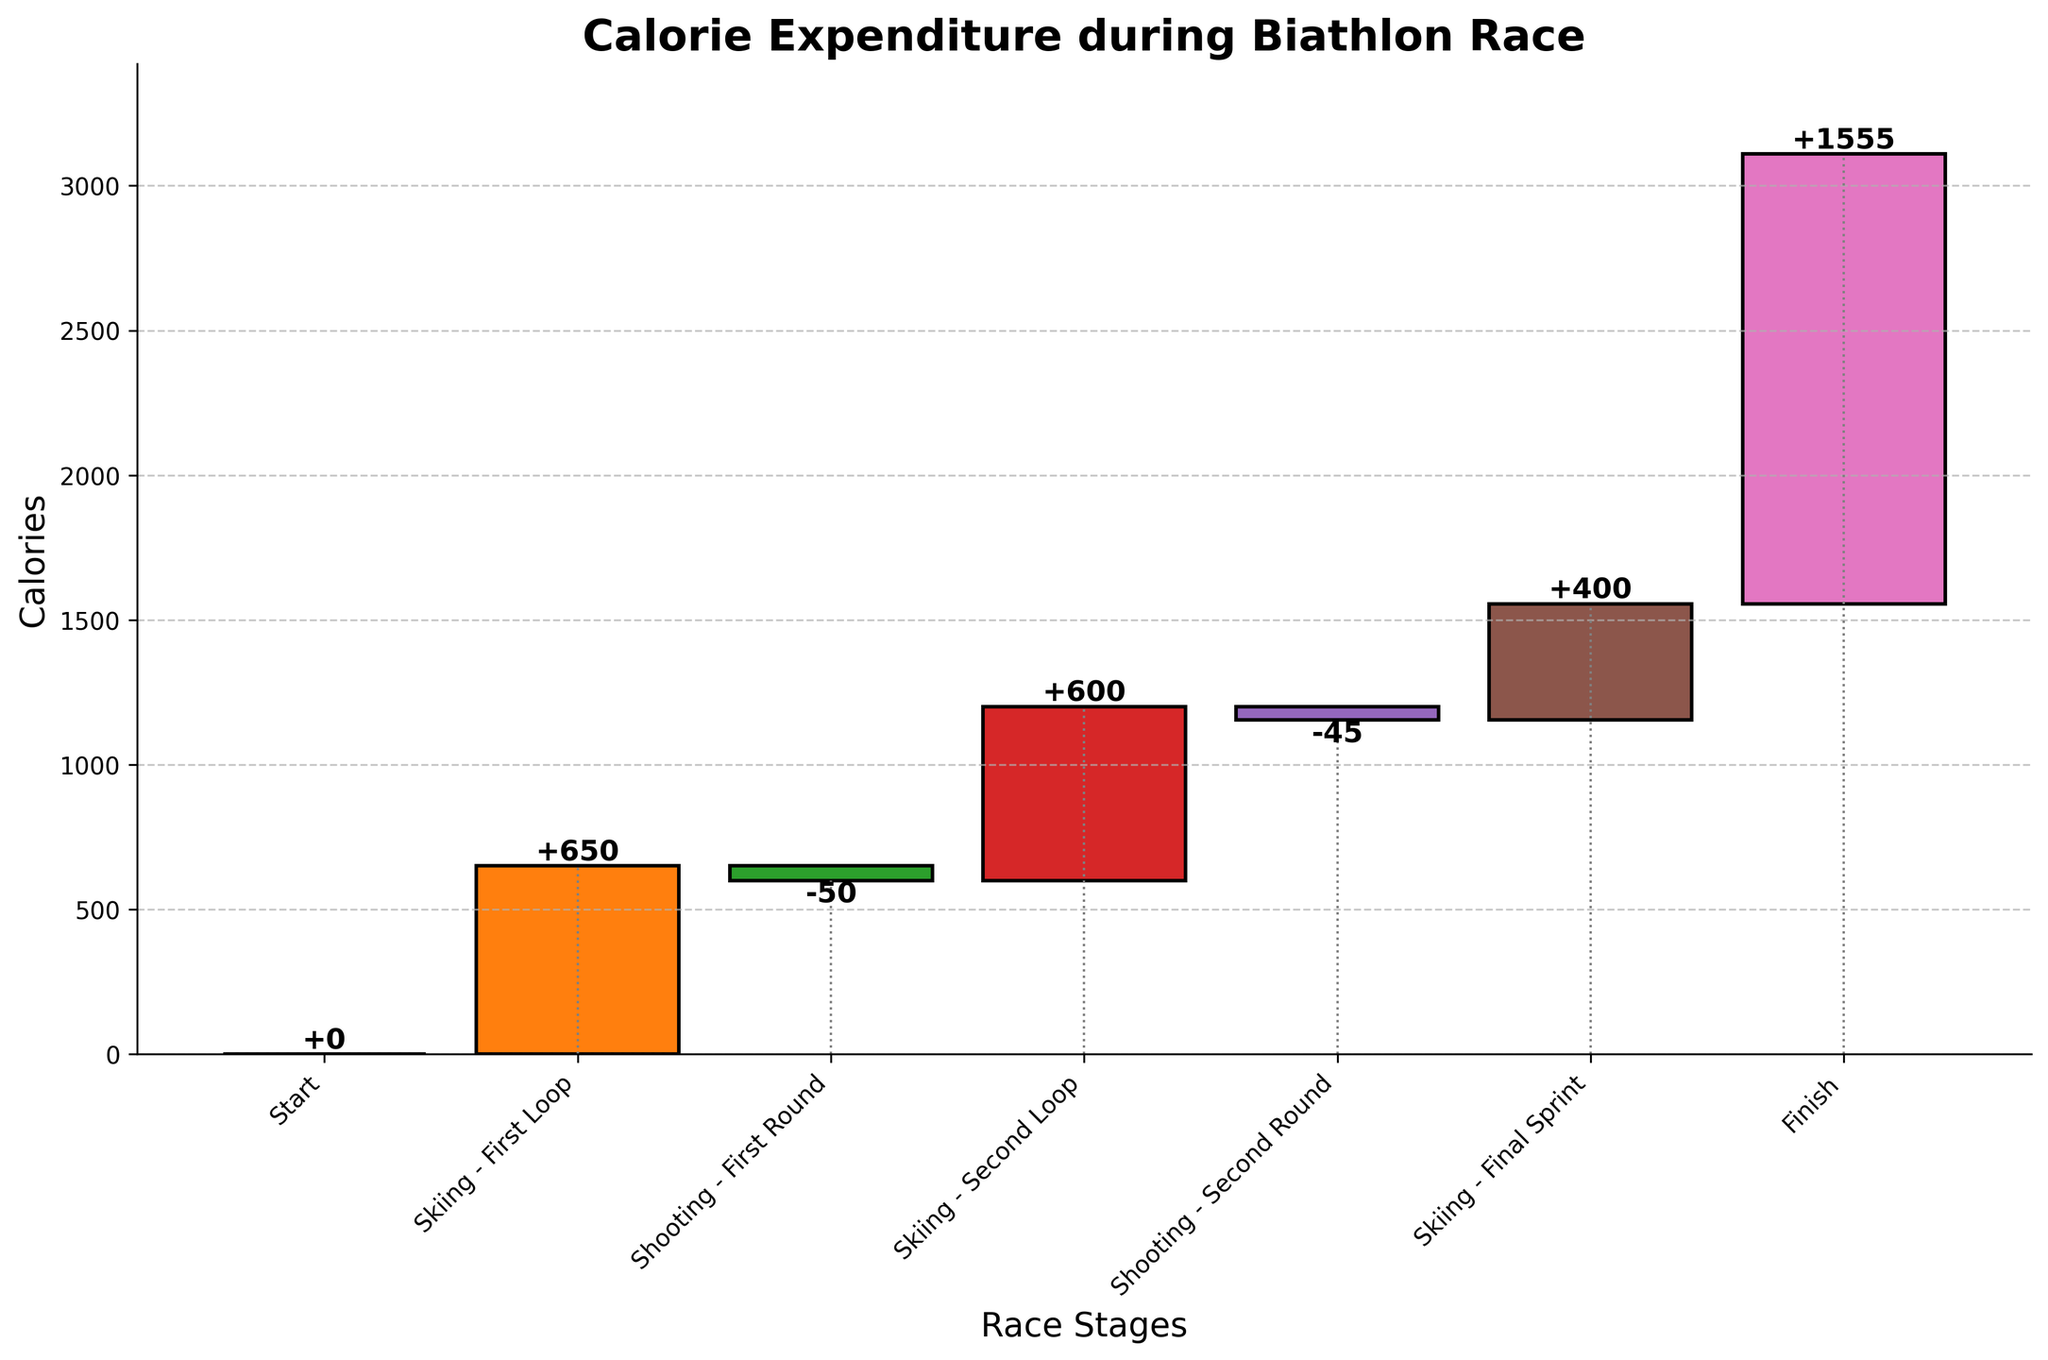What is the title of the chart? The title of the chart is usually displayed at the top or above the main body of the chart. In this case, it reads "Calorie Expenditure during Biathlon Race".
Answer: Calorie Expenditure during Biathlon Race How many distinct stages are there in the biathlon race according to the chart? To determine the number of distinct stages, count the number of labeled categories in the x-axis. Each label corresponds to a different stage.
Answer: 7 Which stage in the biathlon race shows a decrease in calorie expenditure? A decrease in calorie expenditure is indicated by a negative value in the waterfall chart. Look for stages with a negative bar.
Answer: Shooting - First Round, Shooting - Second Round What is the total calorie expenditure at the finish line? The cumulative sum at the end of the race shows the total calorie expenditure. The final value on the y-axis at the "Finish" category represents this.
Answer: 1555 How many calories are expended during the second skiing loop? Identify the bar corresponding to "Skiing - Second Loop" and read the positive value associated with it.
Answer: 600 What is the total calorie expenditure just after the first round of shooting? Sum the calorie values for "Start", "Skiing - First Loop", and "Shooting - First Round". The cumulative sum will give the total expenditure after the first round of shooting.
Answer: 600 How does the calorie expenditure during the final sprint compare to the second skiing loop? Compare the value of "Skiing - Final Sprint" to "Skiing - Second Loop" by examining their respective values.
Answer: Final Sprint = 400, Second Loop = 600; Less in Sprint Which stage contributes the most to the calorie expenditure? Identify the stage with the highest positive value in the chart. Examine each bar's value if necessary.
Answer: Skiing - First Loop (650) What is the average calorie expenditure per stage, excluding the start and finish? Calculate the average by summing the values of all stages except "Start" and "Finish" and dividing by the number of those stages: (650 - 50 + 600 - 45 + 400) / 5.
Answer: 311 What is the difference in calorie expenditure between the two rounds of shooting? Subtract the value of "Shooting - Second Round" from "Shooting - First Round". Since these are negative values, ensure you account for the signs correctly: -50 - (-45).
Answer: -5 